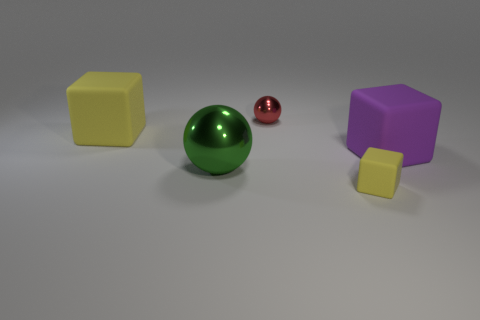Add 2 large yellow objects. How many objects exist? 7 Subtract all spheres. How many objects are left? 3 Add 2 big green metallic spheres. How many big green metallic spheres exist? 3 Subtract 0 yellow spheres. How many objects are left? 5 Subtract all green metallic balls. Subtract all big cubes. How many objects are left? 2 Add 2 yellow rubber objects. How many yellow rubber objects are left? 4 